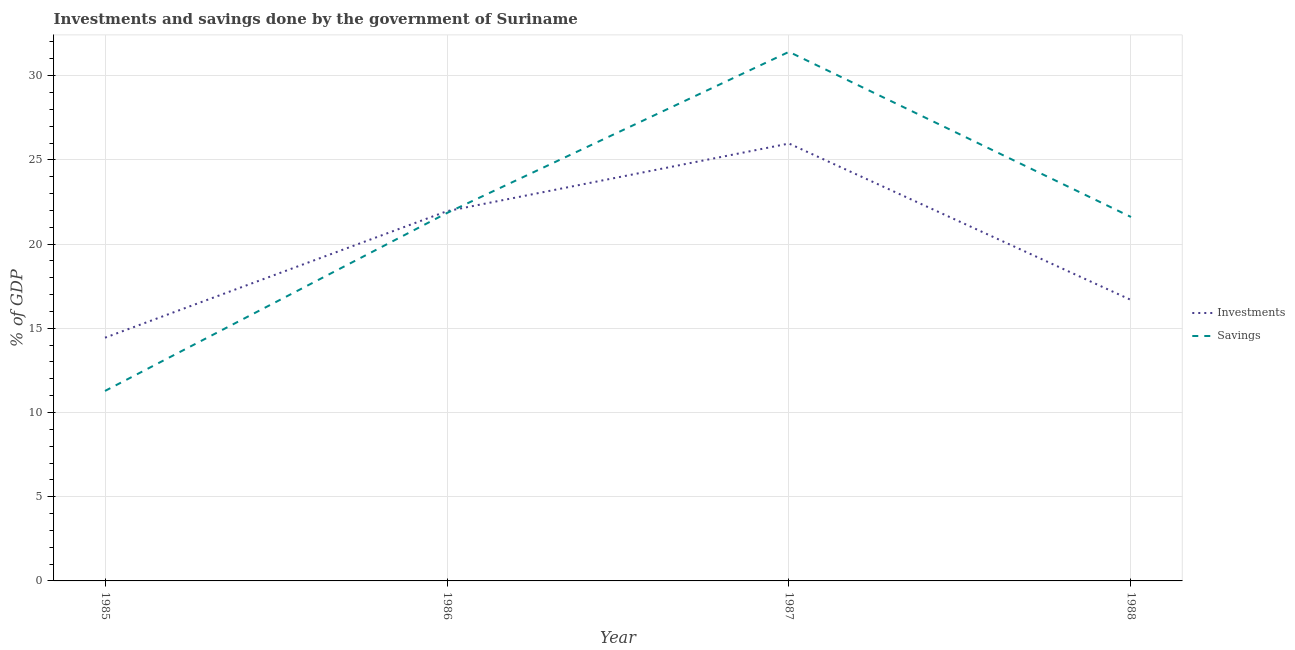Is the number of lines equal to the number of legend labels?
Make the answer very short. Yes. What is the investments of government in 1985?
Your answer should be very brief. 14.44. Across all years, what is the maximum investments of government?
Your answer should be compact. 25.97. Across all years, what is the minimum investments of government?
Your answer should be very brief. 14.44. In which year was the savings of government minimum?
Make the answer very short. 1985. What is the total investments of government in the graph?
Your answer should be very brief. 79.04. What is the difference between the investments of government in 1987 and that in 1988?
Keep it short and to the point. 9.29. What is the difference between the savings of government in 1986 and the investments of government in 1987?
Make the answer very short. -4.12. What is the average savings of government per year?
Provide a succinct answer. 21.54. In the year 1985, what is the difference between the savings of government and investments of government?
Provide a succinct answer. -3.16. What is the ratio of the savings of government in 1985 to that in 1988?
Keep it short and to the point. 0.52. Is the difference between the investments of government in 1986 and 1987 greater than the difference between the savings of government in 1986 and 1987?
Ensure brevity in your answer.  Yes. What is the difference between the highest and the second highest savings of government?
Provide a succinct answer. 9.57. What is the difference between the highest and the lowest investments of government?
Provide a short and direct response. 11.53. In how many years, is the investments of government greater than the average investments of government taken over all years?
Your answer should be very brief. 2. Is the sum of the savings of government in 1986 and 1988 greater than the maximum investments of government across all years?
Give a very brief answer. Yes. Does the investments of government monotonically increase over the years?
Your answer should be compact. No. How many legend labels are there?
Make the answer very short. 2. How are the legend labels stacked?
Keep it short and to the point. Vertical. What is the title of the graph?
Provide a succinct answer. Investments and savings done by the government of Suriname. What is the label or title of the Y-axis?
Your answer should be very brief. % of GDP. What is the % of GDP of Investments in 1985?
Provide a succinct answer. 14.44. What is the % of GDP in Savings in 1985?
Keep it short and to the point. 11.28. What is the % of GDP of Investments in 1986?
Give a very brief answer. 21.95. What is the % of GDP of Savings in 1986?
Offer a very short reply. 21.85. What is the % of GDP in Investments in 1987?
Your answer should be compact. 25.97. What is the % of GDP of Savings in 1987?
Offer a terse response. 31.41. What is the % of GDP in Investments in 1988?
Offer a terse response. 16.68. What is the % of GDP in Savings in 1988?
Offer a very short reply. 21.61. Across all years, what is the maximum % of GDP of Investments?
Keep it short and to the point. 25.97. Across all years, what is the maximum % of GDP of Savings?
Keep it short and to the point. 31.41. Across all years, what is the minimum % of GDP of Investments?
Your answer should be compact. 14.44. Across all years, what is the minimum % of GDP of Savings?
Your answer should be compact. 11.28. What is the total % of GDP of Investments in the graph?
Your response must be concise. 79.04. What is the total % of GDP of Savings in the graph?
Keep it short and to the point. 86.15. What is the difference between the % of GDP in Investments in 1985 and that in 1986?
Keep it short and to the point. -7.51. What is the difference between the % of GDP in Savings in 1985 and that in 1986?
Your response must be concise. -10.57. What is the difference between the % of GDP of Investments in 1985 and that in 1987?
Give a very brief answer. -11.53. What is the difference between the % of GDP of Savings in 1985 and that in 1987?
Your response must be concise. -20.13. What is the difference between the % of GDP in Investments in 1985 and that in 1988?
Your answer should be very brief. -2.24. What is the difference between the % of GDP of Savings in 1985 and that in 1988?
Offer a terse response. -10.33. What is the difference between the % of GDP in Investments in 1986 and that in 1987?
Offer a terse response. -4.02. What is the difference between the % of GDP of Savings in 1986 and that in 1987?
Give a very brief answer. -9.57. What is the difference between the % of GDP in Investments in 1986 and that in 1988?
Your answer should be very brief. 5.27. What is the difference between the % of GDP of Savings in 1986 and that in 1988?
Offer a terse response. 0.24. What is the difference between the % of GDP in Investments in 1987 and that in 1988?
Make the answer very short. 9.29. What is the difference between the % of GDP of Savings in 1987 and that in 1988?
Provide a short and direct response. 9.8. What is the difference between the % of GDP of Investments in 1985 and the % of GDP of Savings in 1986?
Ensure brevity in your answer.  -7.41. What is the difference between the % of GDP in Investments in 1985 and the % of GDP in Savings in 1987?
Provide a succinct answer. -16.97. What is the difference between the % of GDP in Investments in 1985 and the % of GDP in Savings in 1988?
Your response must be concise. -7.17. What is the difference between the % of GDP of Investments in 1986 and the % of GDP of Savings in 1987?
Keep it short and to the point. -9.46. What is the difference between the % of GDP of Investments in 1986 and the % of GDP of Savings in 1988?
Offer a terse response. 0.34. What is the difference between the % of GDP in Investments in 1987 and the % of GDP in Savings in 1988?
Provide a short and direct response. 4.36. What is the average % of GDP of Investments per year?
Ensure brevity in your answer.  19.76. What is the average % of GDP in Savings per year?
Your answer should be compact. 21.54. In the year 1985, what is the difference between the % of GDP in Investments and % of GDP in Savings?
Your answer should be compact. 3.16. In the year 1986, what is the difference between the % of GDP of Investments and % of GDP of Savings?
Your response must be concise. 0.11. In the year 1987, what is the difference between the % of GDP in Investments and % of GDP in Savings?
Give a very brief answer. -5.44. In the year 1988, what is the difference between the % of GDP in Investments and % of GDP in Savings?
Your response must be concise. -4.93. What is the ratio of the % of GDP in Investments in 1985 to that in 1986?
Your answer should be very brief. 0.66. What is the ratio of the % of GDP of Savings in 1985 to that in 1986?
Ensure brevity in your answer.  0.52. What is the ratio of the % of GDP in Investments in 1985 to that in 1987?
Provide a short and direct response. 0.56. What is the ratio of the % of GDP in Savings in 1985 to that in 1987?
Your answer should be very brief. 0.36. What is the ratio of the % of GDP of Investments in 1985 to that in 1988?
Offer a very short reply. 0.87. What is the ratio of the % of GDP in Savings in 1985 to that in 1988?
Provide a succinct answer. 0.52. What is the ratio of the % of GDP in Investments in 1986 to that in 1987?
Your answer should be compact. 0.85. What is the ratio of the % of GDP of Savings in 1986 to that in 1987?
Offer a terse response. 0.7. What is the ratio of the % of GDP in Investments in 1986 to that in 1988?
Keep it short and to the point. 1.32. What is the ratio of the % of GDP in Savings in 1986 to that in 1988?
Offer a terse response. 1.01. What is the ratio of the % of GDP of Investments in 1987 to that in 1988?
Your answer should be compact. 1.56. What is the ratio of the % of GDP in Savings in 1987 to that in 1988?
Offer a terse response. 1.45. What is the difference between the highest and the second highest % of GDP of Investments?
Offer a terse response. 4.02. What is the difference between the highest and the second highest % of GDP in Savings?
Give a very brief answer. 9.57. What is the difference between the highest and the lowest % of GDP in Investments?
Make the answer very short. 11.53. What is the difference between the highest and the lowest % of GDP of Savings?
Make the answer very short. 20.13. 